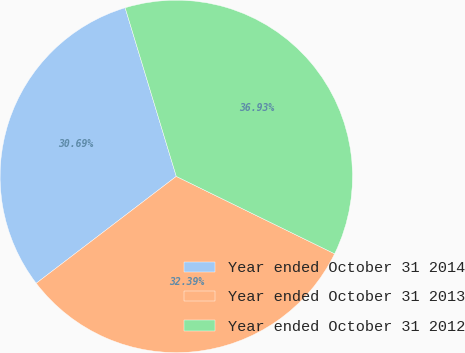Convert chart. <chart><loc_0><loc_0><loc_500><loc_500><pie_chart><fcel>Year ended October 31 2014<fcel>Year ended October 31 2013<fcel>Year ended October 31 2012<nl><fcel>30.69%<fcel>32.39%<fcel>36.93%<nl></chart> 